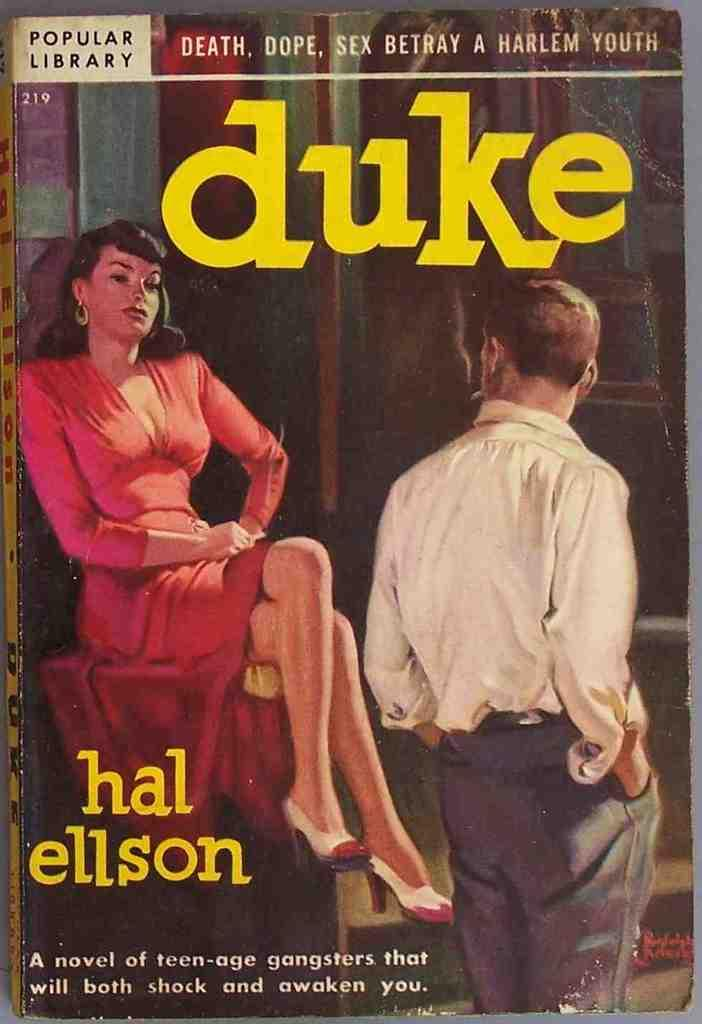<image>
Provide a brief description of the given image. A cover of a book titled Duke with an image of a woman in a red dress. 